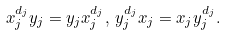Convert formula to latex. <formula><loc_0><loc_0><loc_500><loc_500>x _ { j } ^ { d _ { j } } y _ { j } = y _ { j } x _ { j } ^ { d _ { j } } , \, y _ { j } ^ { d _ { j } } x _ { j } = x _ { j } y _ { j } ^ { d _ { j } } .</formula> 